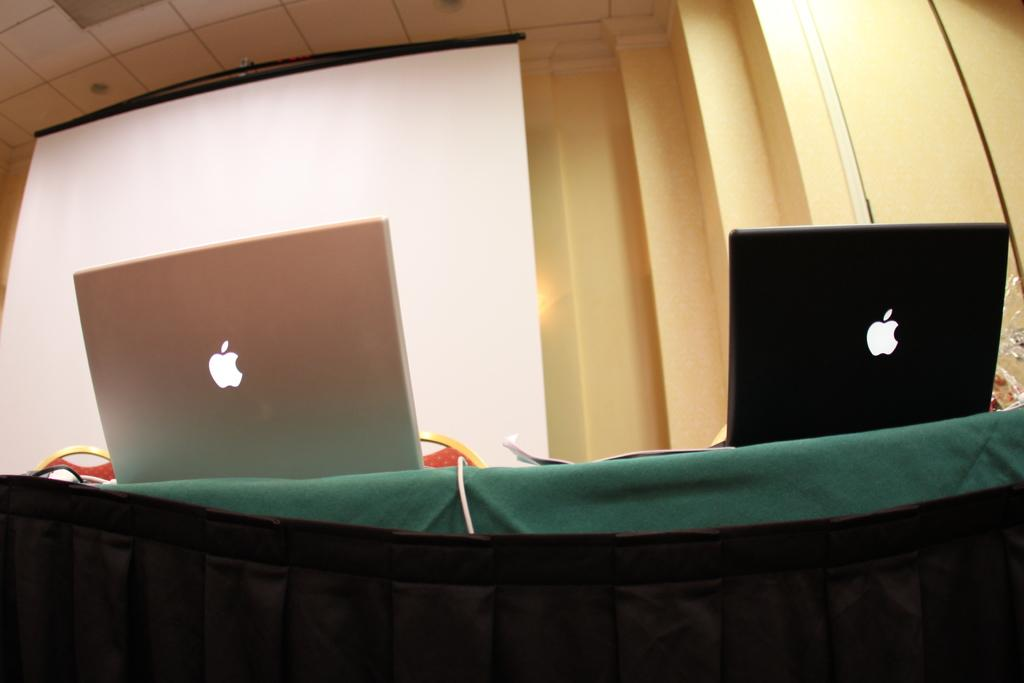What is the main piece of furniture in the image? There is a table in the image. What electronic devices are on the table? There are two Apple laptops on the table. What can be seen in the background of the image? There is a screen and a wall in the background of the image. Who is the representative of the company in the image? There is no representative of a company present in the image. Can you see the father of the family in the image? There is no father or family members present in the image. 